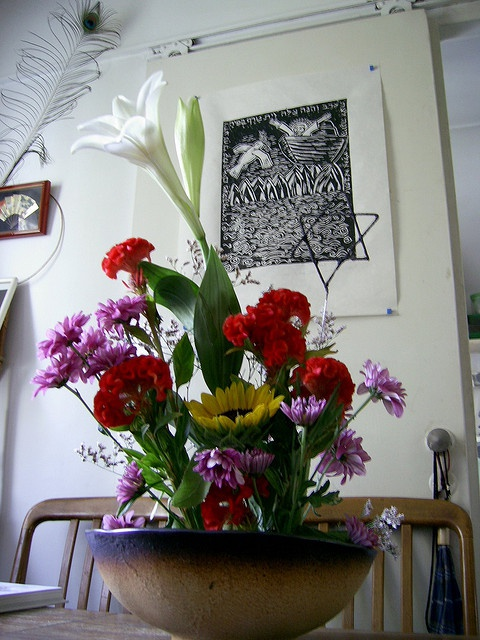Describe the objects in this image and their specific colors. I can see bench in gray, black, and darkgray tones, bowl in gray, black, and maroon tones, chair in gray and black tones, chair in gray, darkgray, and black tones, and dining table in gray tones in this image. 